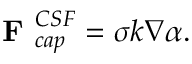<formula> <loc_0><loc_0><loc_500><loc_500>F _ { c a p } ^ { C S F } = \sigma k \nabla \alpha .</formula> 